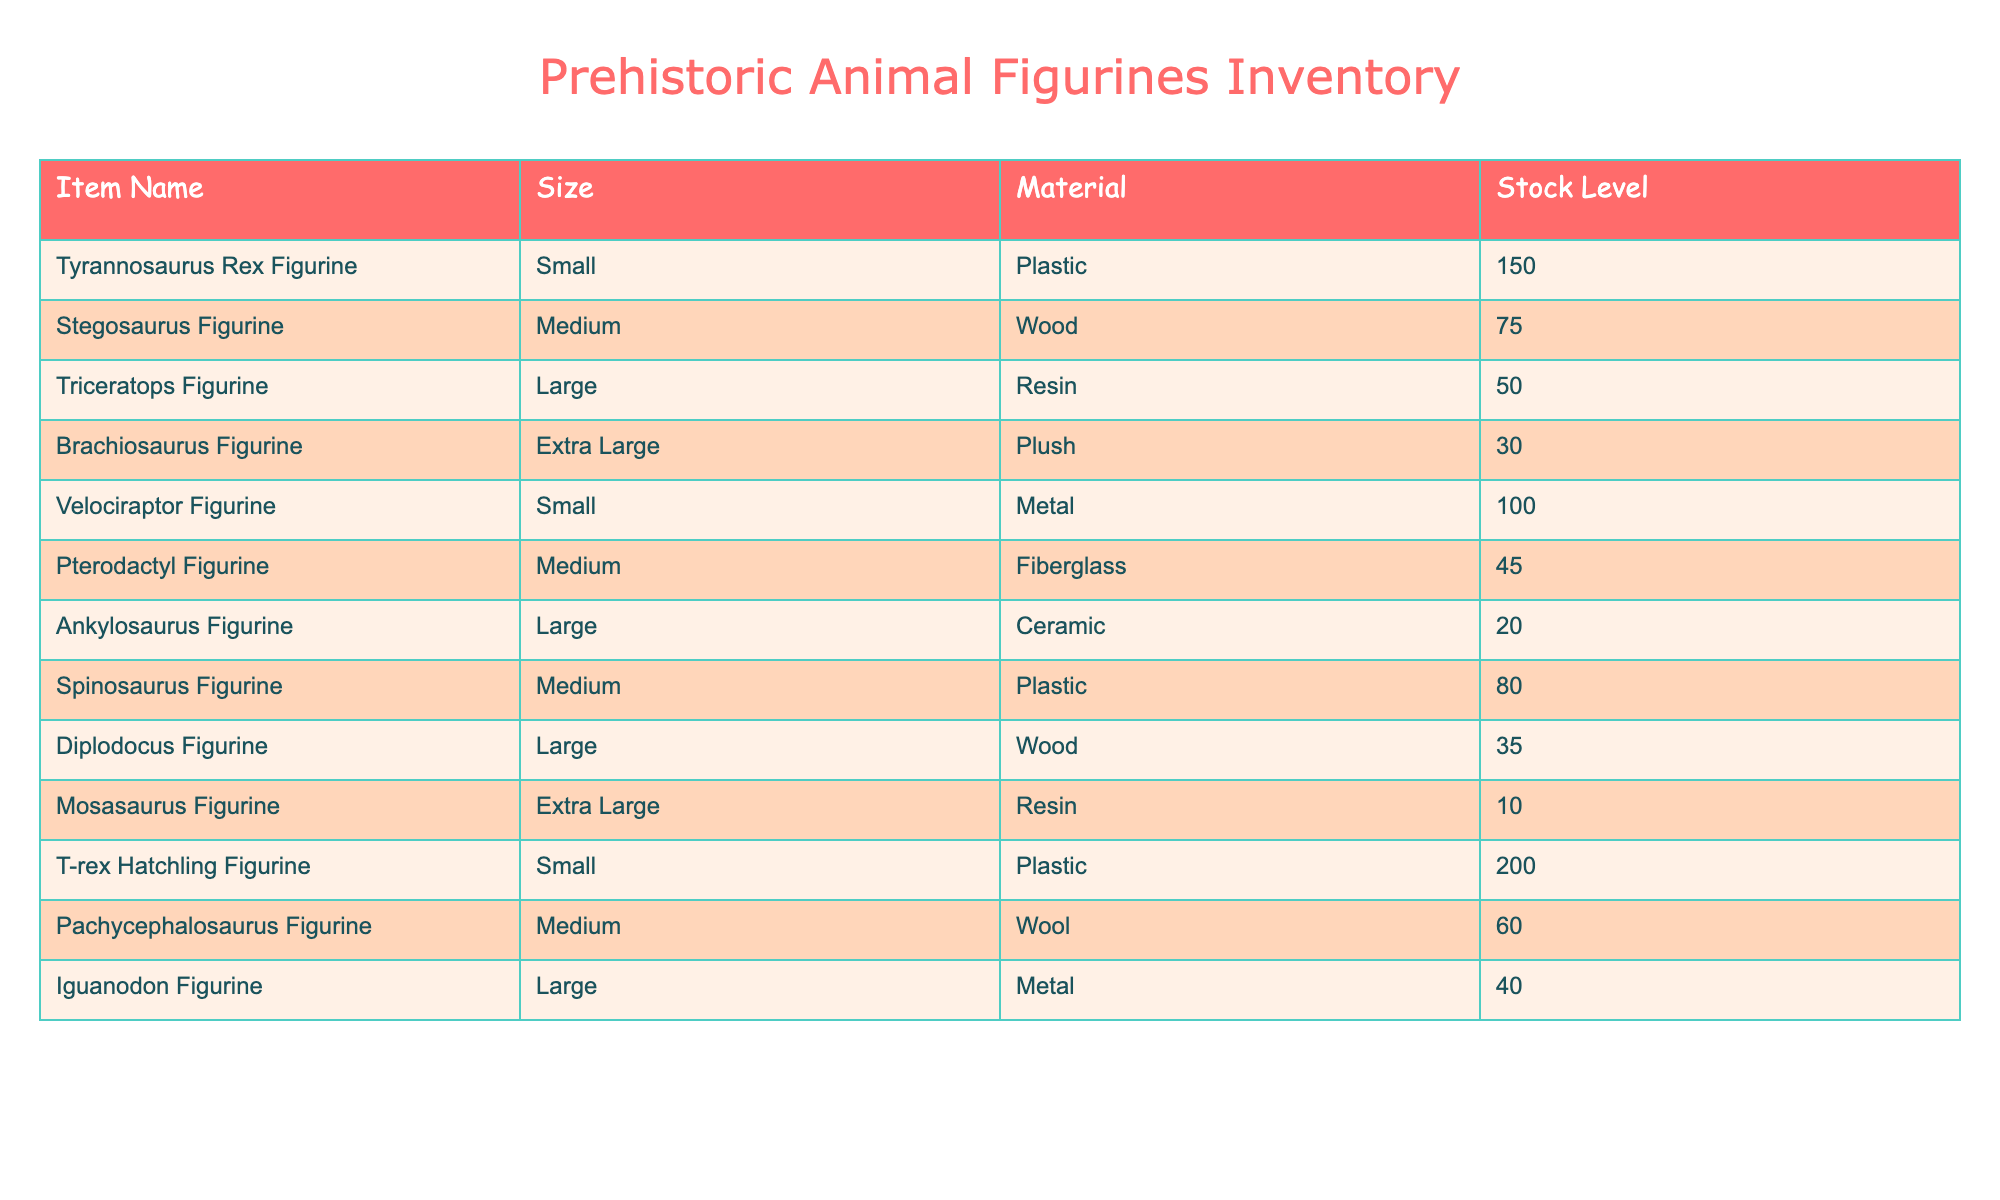What is the stock level of the Tyrannosaurus Rex figurine? The stock level of the Tyrannosaurus Rex figurine can be found directly in the table under the corresponding row, which shows that it has a stock level of 150.
Answer: 150 How many more Triceratops figurines are there than Ankylosaurus figurines? The Triceratops figurine has a stock level of 50, while the Ankylosaurus figurine has a stock level of 20. The difference is 50 - 20 = 30.
Answer: 30 Is the stock level of the Pterodactyl figurine greater than 50? The stock level of the Pterodactyl figurine is listed as 45 in the table, which is less than 50. Therefore, the answer is no.
Answer: No What is the total stock level of all Medium-sized figurines? The total stock for Medium-sized figurines includes the Stegosaurus (75), Pterodactyl (45), Spinosaurus (80), and Pachycephalosaurus (60). Summing these gives 75 + 45 + 80 + 60 = 260.
Answer: 260 How many figurines are available in Extra Large size? Referring to the table, the only Extra Large figurines listed are the Brachiosaurus (30) and Mosasaurus (10). Adding these gives a total of 30 + 10 = 40.
Answer: 40 Are there any Metal figurines available in stock? From the table, we can see that there are two Metal figurines: the Velociraptor (100) and Iguanodon (40), both of which have stock levels above zero. Therefore, the answer is yes.
Answer: Yes What is the average stock level for Large figurines? The Large figurines in the table are Triceratops (50), Ankylosaurus (20), and Diplodocus (35). To find the average, we first calculate the total stock: 50 + 20 + 35 = 105. Then, we divide by the number of Large figurines, which is 3. Thus, the average is 105 / 3 = 35.
Answer: 35 How many Small figurines are in stock combined? The Small figurines are the Tyrannosaurus Rex (150) and Velociraptor (100), as well as the T-rex Hatchling (200). Adding these gives a total of 150 + 100 + 200 = 450.
Answer: 450 